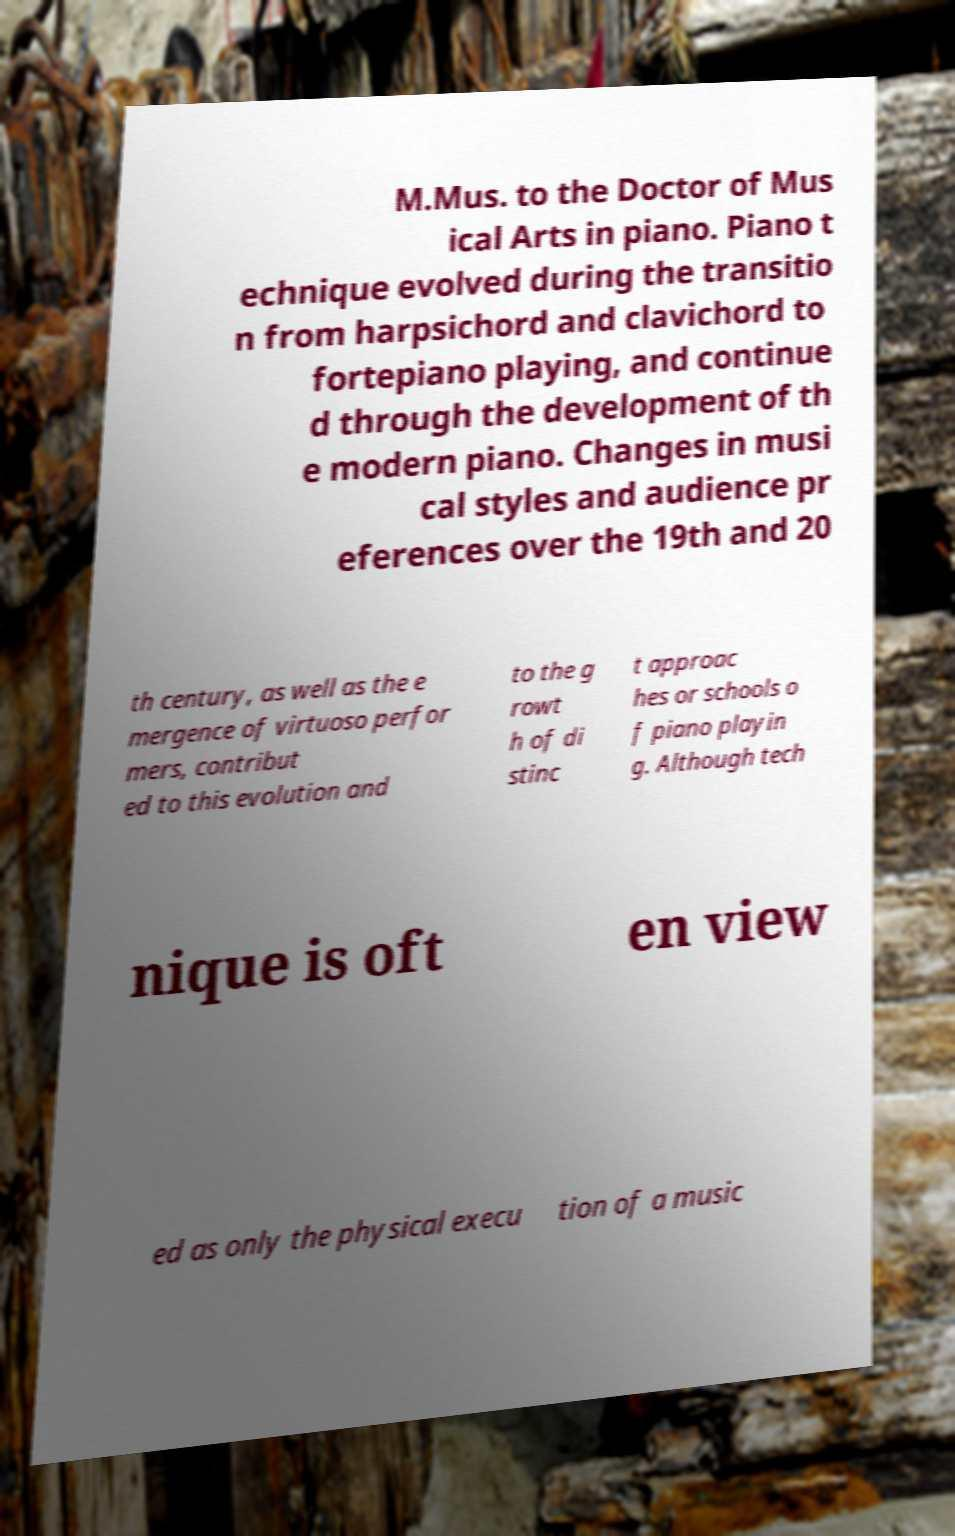Could you extract and type out the text from this image? M.Mus. to the Doctor of Mus ical Arts in piano. Piano t echnique evolved during the transitio n from harpsichord and clavichord to fortepiano playing, and continue d through the development of th e modern piano. Changes in musi cal styles and audience pr eferences over the 19th and 20 th century, as well as the e mergence of virtuoso perfor mers, contribut ed to this evolution and to the g rowt h of di stinc t approac hes or schools o f piano playin g. Although tech nique is oft en view ed as only the physical execu tion of a music 